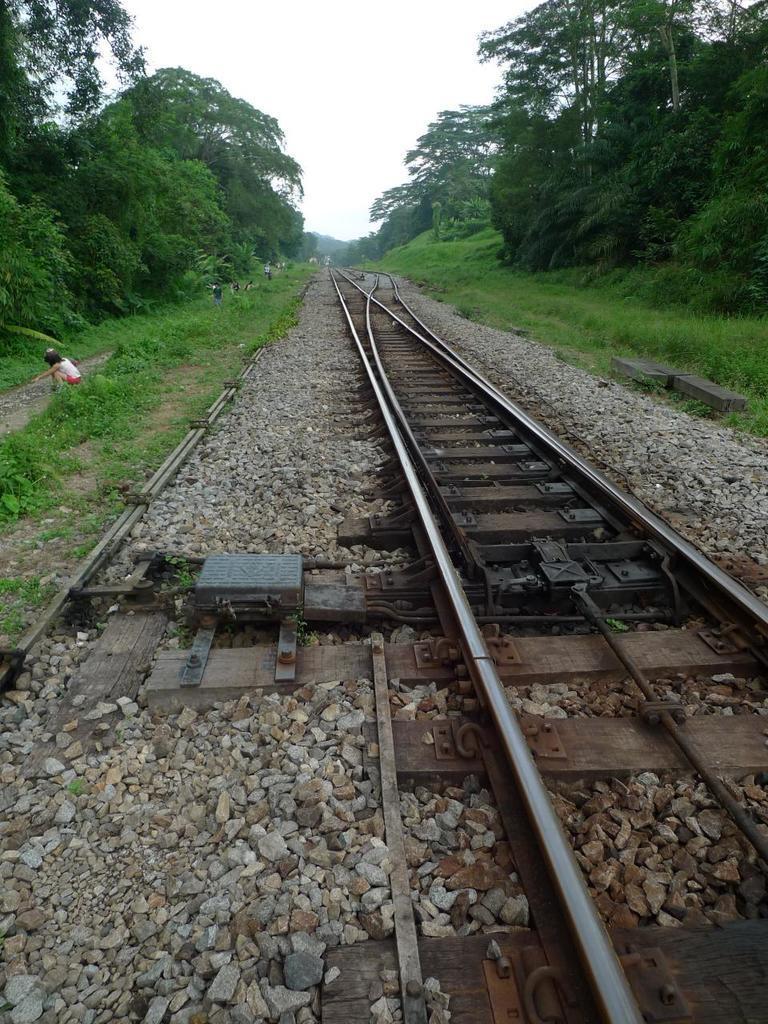How would you summarize this image in a sentence or two? In this picture I can see the railway tracks in the middle, on the left side there is a person. There are trees on either side of this image, at the top I can see the sky. 